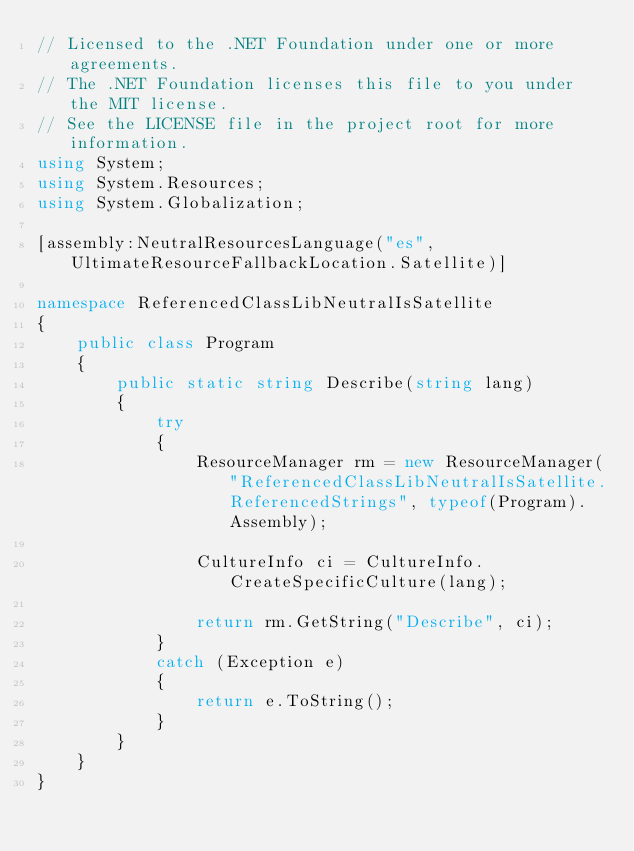Convert code to text. <code><loc_0><loc_0><loc_500><loc_500><_C#_>// Licensed to the .NET Foundation under one or more agreements.
// The .NET Foundation licenses this file to you under the MIT license.
// See the LICENSE file in the project root for more information.
using System;
using System.Resources;
using System.Globalization;

[assembly:NeutralResourcesLanguage("es", UltimateResourceFallbackLocation.Satellite)]

namespace ReferencedClassLibNeutralIsSatellite
{
    public class Program
    {
        public static string Describe(string lang)
        {
            try
            {
                ResourceManager rm = new ResourceManager("ReferencedClassLibNeutralIsSatellite.ReferencedStrings", typeof(Program).Assembly);

                CultureInfo ci = CultureInfo.CreateSpecificCulture(lang);

                return rm.GetString("Describe", ci);
            }
            catch (Exception e)
            {
                return e.ToString();
            }
        }
    }
}
</code> 